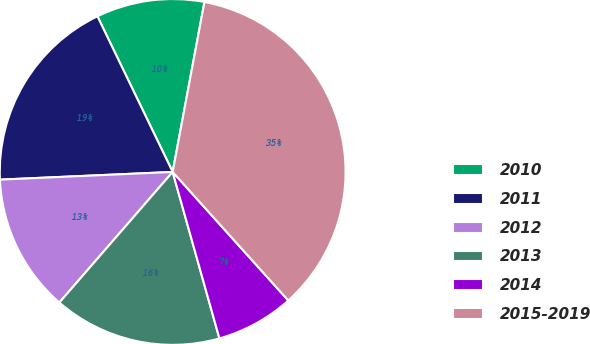Convert chart. <chart><loc_0><loc_0><loc_500><loc_500><pie_chart><fcel>2010<fcel>2011<fcel>2012<fcel>2013<fcel>2014<fcel>2015-2019<nl><fcel>10.11%<fcel>18.54%<fcel>12.92%<fcel>15.73%<fcel>7.3%<fcel>35.4%<nl></chart> 